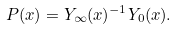<formula> <loc_0><loc_0><loc_500><loc_500>P ( x ) = Y _ { \infty } ( x ) ^ { - 1 } Y _ { 0 } ( x ) .</formula> 